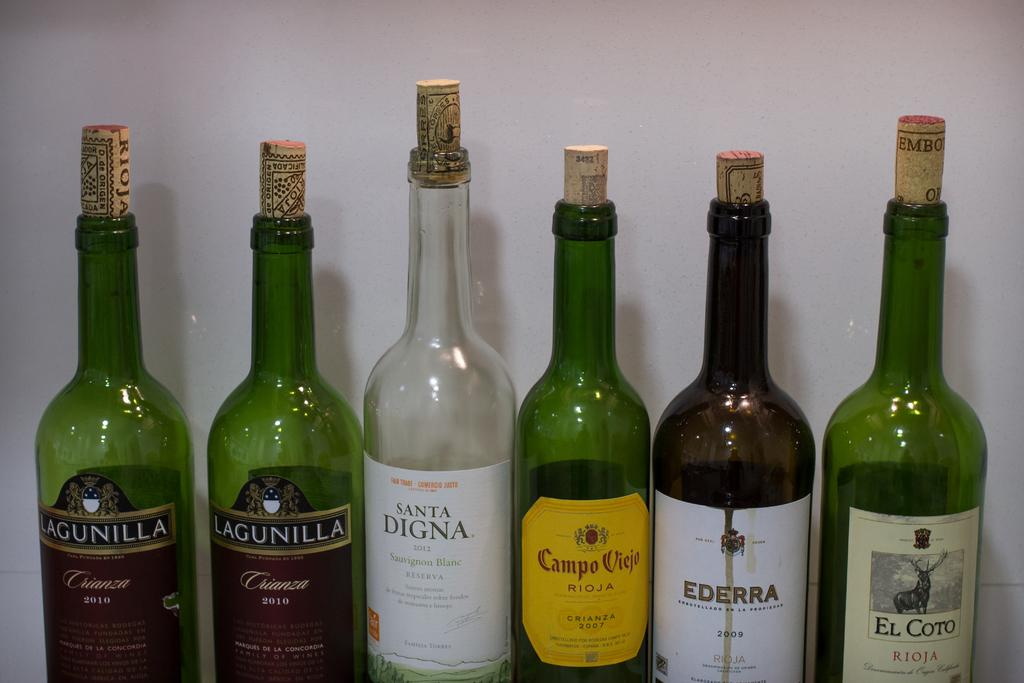How many bottles are present in the image? There are six bottles in the image. What do all the bottles have in common? All bottles have corks and labels. What colors are the bottles? Four bottles are green, one is white, and one is brown. What type of crayon can be seen in the image? There is no crayon present in the image. How are the bottles being used in the image? The image does not show the bottles being used, only their appearance. 